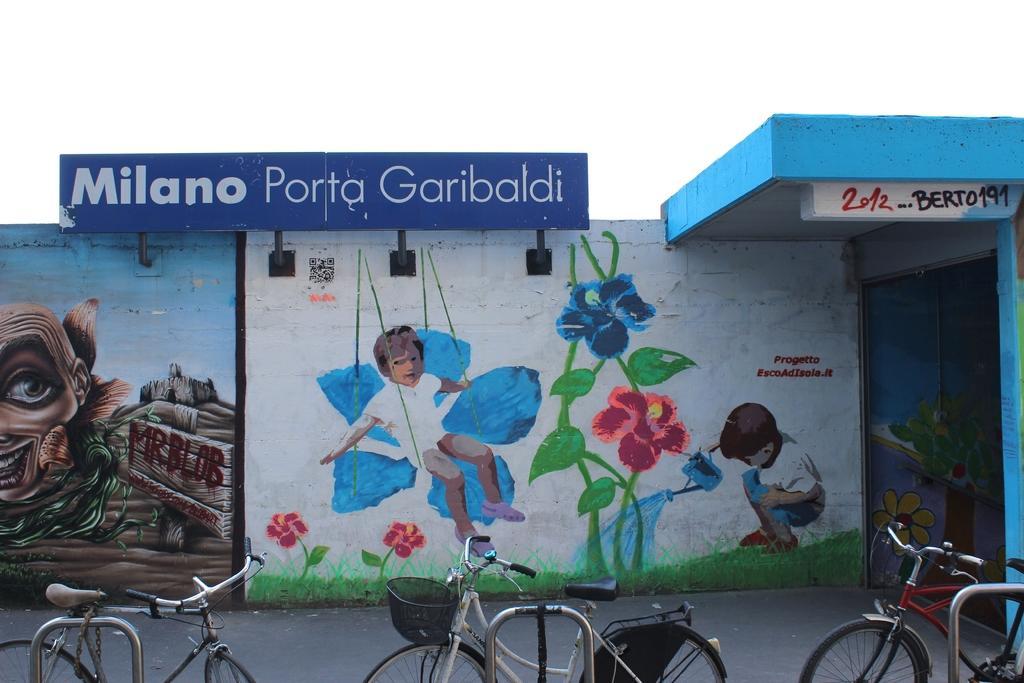Could you give a brief overview of what you see in this image? In the image in the center there is a banner,wall and some painting on it. In which,we can see two kids,flowers etc. In the bottom of the image we can see cycles. In the background we can see the sky and clouds. 